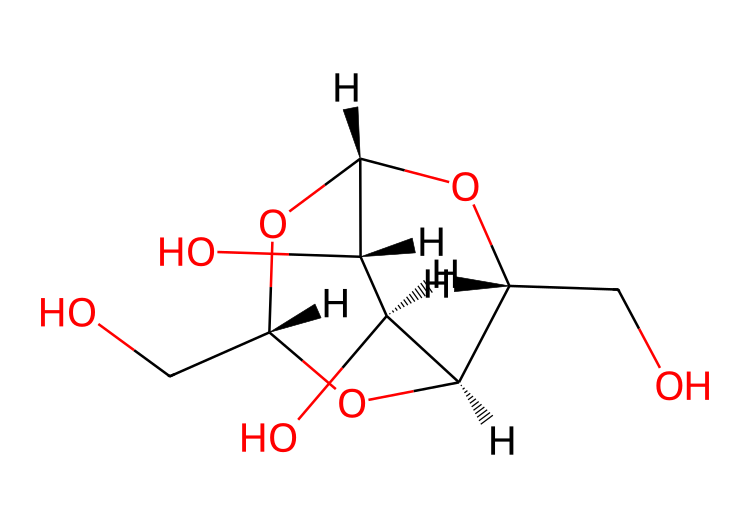What is the molecular formula of this compound? To determine the molecular formula, we identify the elements present from the chemical structure. The structure consists of carbon (C), oxygen (O), and hydrogen (H). Counting the carbon atoms gives us 6, oxygen atoms gives us 6, and hydrogen atoms gives us 10. Thus, the molecular formula is C6H10O6.
Answer: C6H10O6 How many rings are in the structure? By analyzing the SMILES representation, we notice the presence of numbers indicating ring closures. The numbers '1' and '2' signify two separate ring structures that close off in the molecule. Thus, there are two rings present in the structure.
Answer: 2 What type of sugar is indicated by this structure? The connectivity and structure correspond to a polysaccharide made up of repeating units of glucose. This specific structure is that of beta-D-glucose, a common monomer in cellulose.
Answer: glucose What functional groups are present in the structure? Analyzing the structure, we can identify several hydroxyl groups (-OH) attached to the carbon skeleton. The presence of these hydroxyl functional groups suggests that this compound is alcohol-rich, characteristic of sugars.
Answer: hydroxyl groups What is the primary use of this compound? Cellulose is primarily derived from this structure, which is used extensively in paper production. Therefore, the primary use of this compound relates to its application in book publishing and related materials.
Answer: paper production How many oxygen atoms are in the structure? By systematically counting the oxygen atoms indicated within the SMILES notation, we find a total of 6 oxygen atoms integrated into the structure of this compound.
Answer: 6 What characteristic property does cellulose have due to its structure? The extensive hydrogen bonding capacity due to hydroxyl groups facilitates strong intermolecular interactions, leading to cellulose's characteristic property of being structurally stable and insoluble in water.
Answer: insoluble 